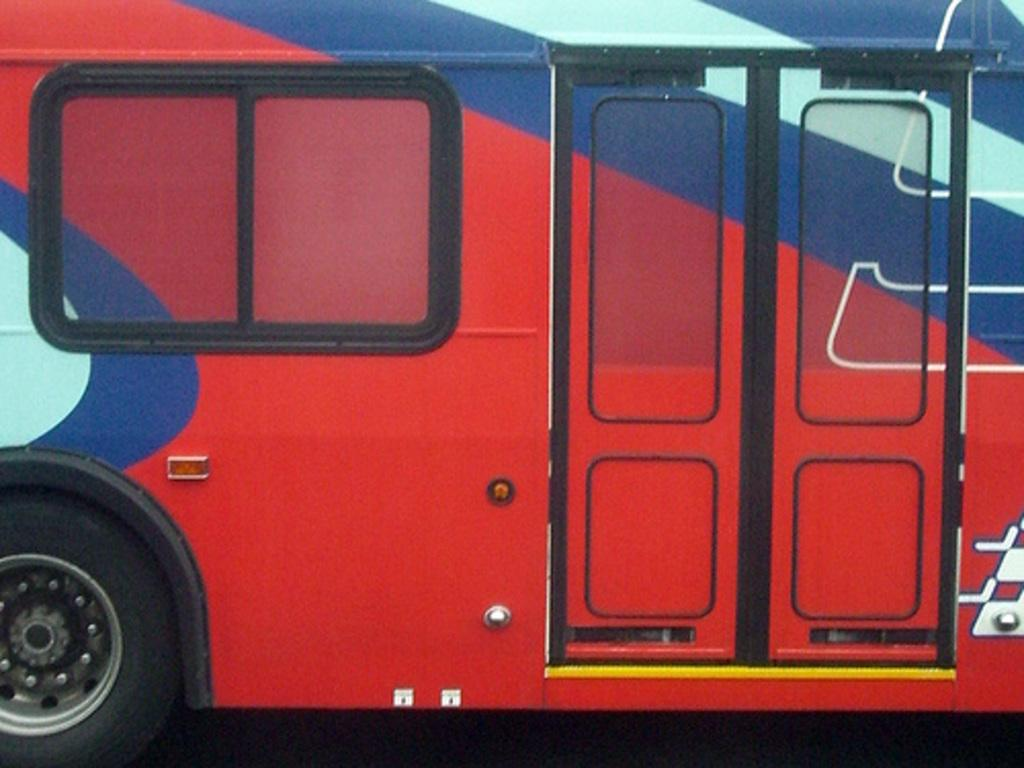What is the main subject of the image? The main subject of the image is a bus. Where is the bus located in the image? The bus is in the center of the image. What color is the bus? The bus is red in color. What type of flowers can be seen growing near the bus in the image? There are no flowers present in the image; it only features a red bus in the center. 